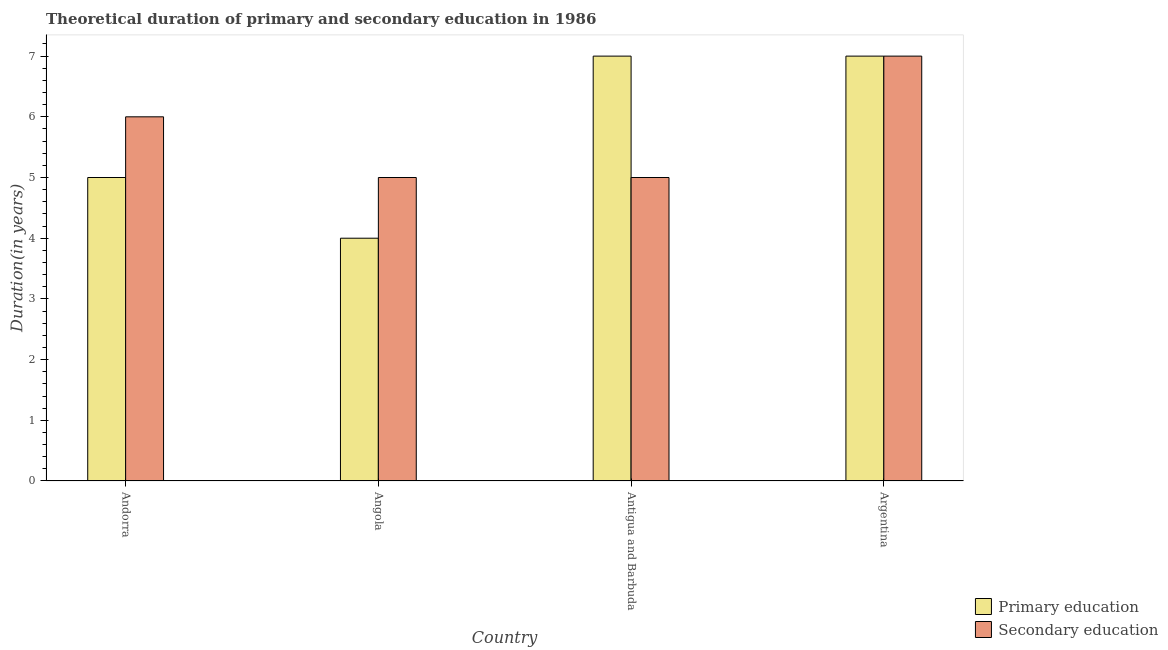How many different coloured bars are there?
Ensure brevity in your answer.  2. How many groups of bars are there?
Offer a very short reply. 4. Are the number of bars per tick equal to the number of legend labels?
Make the answer very short. Yes. Are the number of bars on each tick of the X-axis equal?
Your response must be concise. Yes. How many bars are there on the 3rd tick from the left?
Your answer should be very brief. 2. What is the label of the 2nd group of bars from the left?
Offer a terse response. Angola. Across all countries, what is the maximum duration of primary education?
Your answer should be compact. 7. Across all countries, what is the minimum duration of primary education?
Give a very brief answer. 4. In which country was the duration of secondary education maximum?
Make the answer very short. Argentina. In which country was the duration of primary education minimum?
Provide a succinct answer. Angola. What is the total duration of secondary education in the graph?
Offer a terse response. 23. What is the difference between the duration of secondary education in Antigua and Barbuda and that in Argentina?
Make the answer very short. -2. What is the difference between the duration of primary education in Angola and the duration of secondary education in Antigua and Barbuda?
Give a very brief answer. -1. What is the average duration of primary education per country?
Ensure brevity in your answer.  5.75. What is the difference between the duration of secondary education and duration of primary education in Angola?
Your answer should be compact. 1. In how many countries, is the duration of secondary education greater than 2.8 years?
Make the answer very short. 4. What is the ratio of the duration of primary education in Angola to that in Argentina?
Your answer should be very brief. 0.57. Is the duration of primary education in Andorra less than that in Angola?
Provide a succinct answer. No. Is the difference between the duration of primary education in Andorra and Angola greater than the difference between the duration of secondary education in Andorra and Angola?
Make the answer very short. No. What is the difference between the highest and the second highest duration of primary education?
Provide a succinct answer. 0. What is the difference between the highest and the lowest duration of secondary education?
Offer a terse response. 2. What does the 1st bar from the left in Argentina represents?
Ensure brevity in your answer.  Primary education. What does the 1st bar from the right in Argentina represents?
Keep it short and to the point. Secondary education. Are all the bars in the graph horizontal?
Give a very brief answer. No. What is the difference between two consecutive major ticks on the Y-axis?
Offer a terse response. 1. Where does the legend appear in the graph?
Make the answer very short. Bottom right. How many legend labels are there?
Make the answer very short. 2. What is the title of the graph?
Make the answer very short. Theoretical duration of primary and secondary education in 1986. What is the label or title of the X-axis?
Your answer should be very brief. Country. What is the label or title of the Y-axis?
Offer a terse response. Duration(in years). What is the Duration(in years) of Primary education in Andorra?
Provide a succinct answer. 5. What is the Duration(in years) in Primary education in Angola?
Give a very brief answer. 4. What is the Duration(in years) in Secondary education in Angola?
Provide a short and direct response. 5. What is the Duration(in years) in Primary education in Antigua and Barbuda?
Keep it short and to the point. 7. Across all countries, what is the minimum Duration(in years) of Primary education?
Offer a very short reply. 4. What is the total Duration(in years) of Secondary education in the graph?
Offer a very short reply. 23. What is the difference between the Duration(in years) in Primary education in Andorra and that in Angola?
Provide a succinct answer. 1. What is the difference between the Duration(in years) of Secondary education in Andorra and that in Angola?
Ensure brevity in your answer.  1. What is the difference between the Duration(in years) in Primary education in Andorra and that in Antigua and Barbuda?
Provide a short and direct response. -2. What is the difference between the Duration(in years) of Secondary education in Andorra and that in Antigua and Barbuda?
Your answer should be compact. 1. What is the difference between the Duration(in years) of Secondary education in Andorra and that in Argentina?
Provide a short and direct response. -1. What is the difference between the Duration(in years) of Secondary education in Angola and that in Argentina?
Your response must be concise. -2. What is the difference between the Duration(in years) in Primary education in Antigua and Barbuda and that in Argentina?
Offer a very short reply. 0. What is the difference between the Duration(in years) of Primary education in Andorra and the Duration(in years) of Secondary education in Antigua and Barbuda?
Keep it short and to the point. 0. What is the difference between the Duration(in years) in Primary education in Andorra and the Duration(in years) in Secondary education in Argentina?
Your answer should be very brief. -2. What is the difference between the Duration(in years) of Primary education in Angola and the Duration(in years) of Secondary education in Antigua and Barbuda?
Ensure brevity in your answer.  -1. What is the difference between the Duration(in years) in Primary education in Angola and the Duration(in years) in Secondary education in Argentina?
Your answer should be very brief. -3. What is the average Duration(in years) in Primary education per country?
Your answer should be compact. 5.75. What is the average Duration(in years) of Secondary education per country?
Give a very brief answer. 5.75. What is the difference between the Duration(in years) of Primary education and Duration(in years) of Secondary education in Angola?
Your response must be concise. -1. What is the difference between the Duration(in years) of Primary education and Duration(in years) of Secondary education in Antigua and Barbuda?
Offer a very short reply. 2. What is the ratio of the Duration(in years) of Secondary education in Angola to that in Antigua and Barbuda?
Your answer should be very brief. 1. What is the ratio of the Duration(in years) in Primary education in Antigua and Barbuda to that in Argentina?
Give a very brief answer. 1. What is the ratio of the Duration(in years) of Secondary education in Antigua and Barbuda to that in Argentina?
Provide a succinct answer. 0.71. What is the difference between the highest and the lowest Duration(in years) in Secondary education?
Ensure brevity in your answer.  2. 